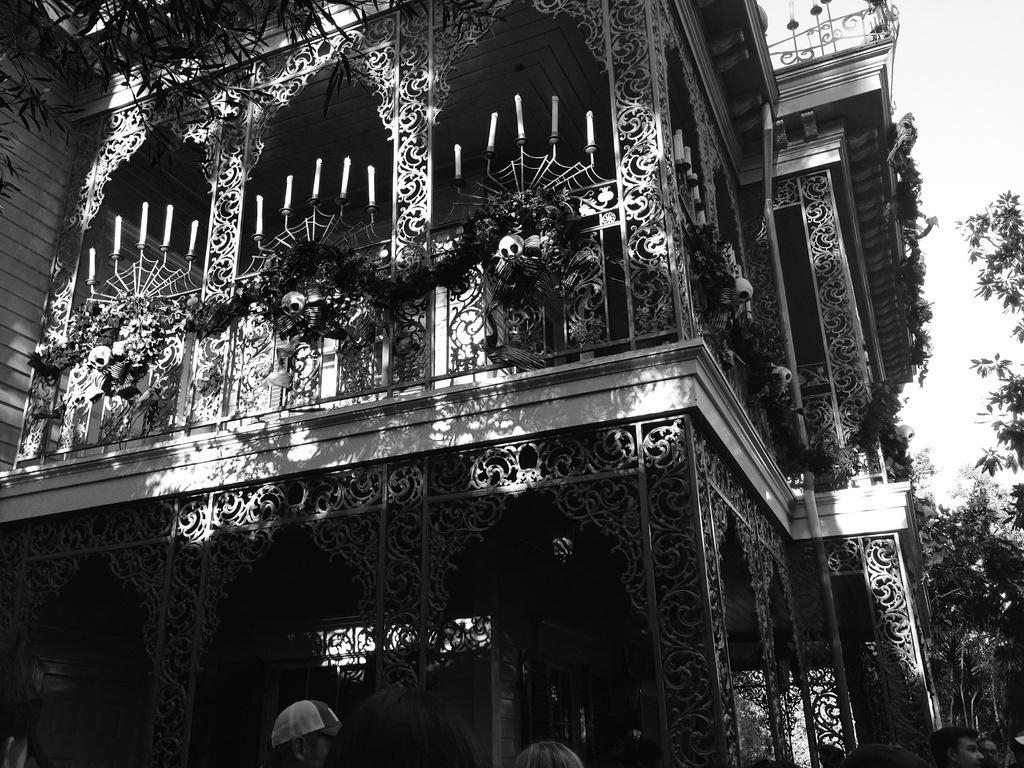Please provide a concise description of this image. In this image we can see a black and white picture of a building with a group of candles placed on it. In the foreground of the image we can see group of people standing. One person wearing a cap. In the background, we can see a group of trees and sky. 